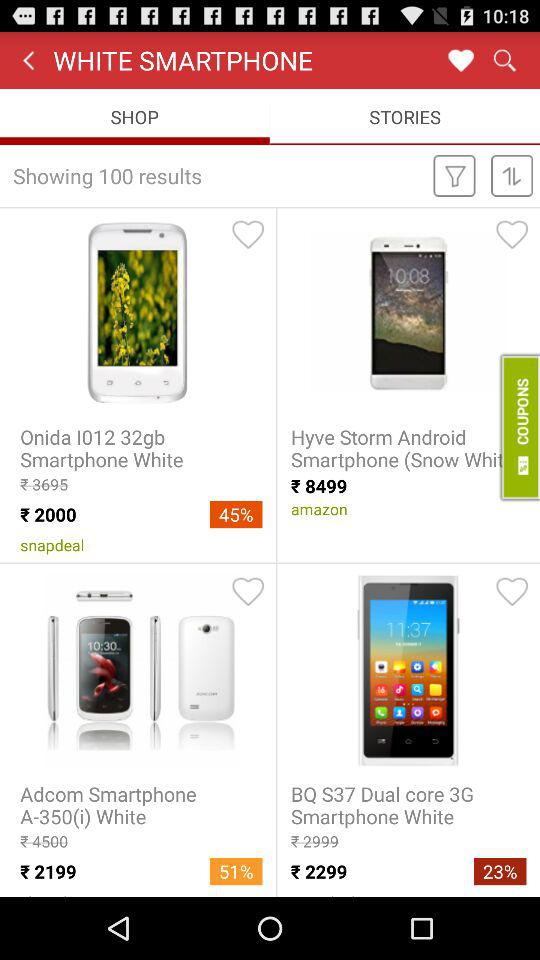What is the discounted price of "Onida I012"? The discounted price of "Onida I012" is 2000 rupees. 